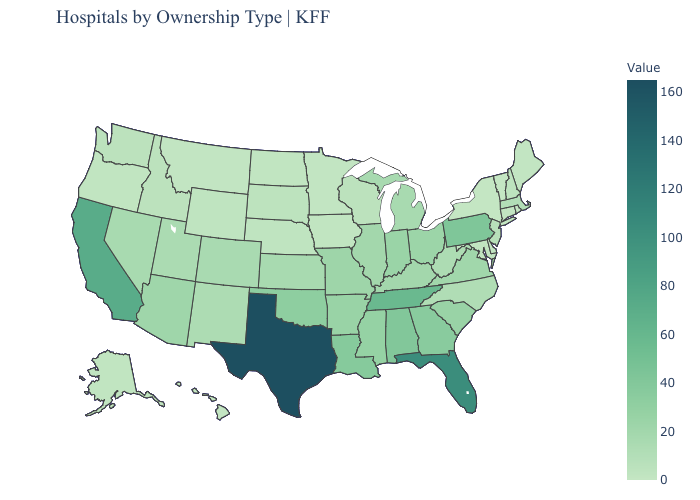Which states have the lowest value in the USA?
Be succinct. Hawaii, New York, Rhode Island, Vermont. Among the states that border Alabama , which have the lowest value?
Short answer required. Mississippi. Which states have the highest value in the USA?
Quick response, please. Texas. Which states have the lowest value in the USA?
Keep it brief. Hawaii, New York, Rhode Island, Vermont. 